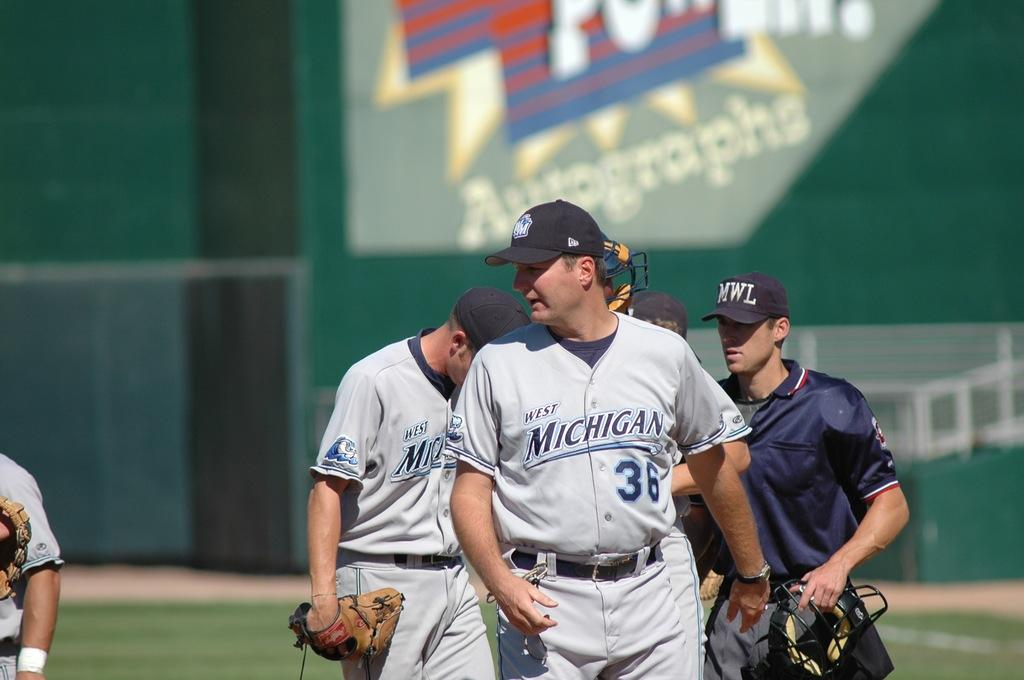<image>
Create a compact narrative representing the image presented. baseball players from Michigan walk off a field 